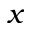<formula> <loc_0><loc_0><loc_500><loc_500>x</formula> 